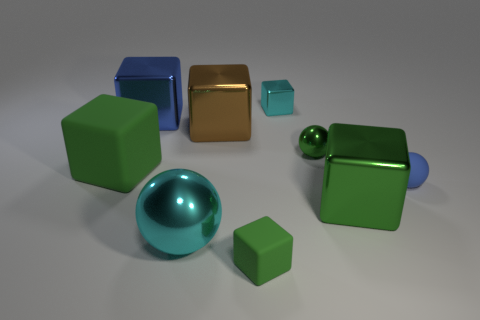Subtract all brown metal cubes. How many cubes are left? 5 Subtract all green blocks. How many blocks are left? 3 Add 1 brown blocks. How many objects exist? 10 Subtract all balls. How many objects are left? 6 Add 1 large cyan balls. How many large cyan balls exist? 2 Subtract 0 purple blocks. How many objects are left? 9 Subtract 5 cubes. How many cubes are left? 1 Subtract all blue cubes. Subtract all green cylinders. How many cubes are left? 5 Subtract all blue cylinders. How many brown blocks are left? 1 Subtract all brown cubes. Subtract all blue things. How many objects are left? 6 